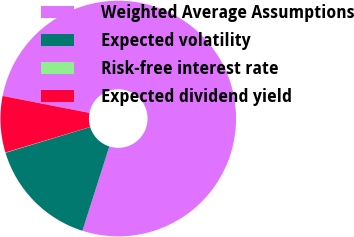Convert chart. <chart><loc_0><loc_0><loc_500><loc_500><pie_chart><fcel>Weighted Average Assumptions<fcel>Expected volatility<fcel>Risk-free interest rate<fcel>Expected dividend yield<nl><fcel>76.83%<fcel>15.4%<fcel>0.04%<fcel>7.72%<nl></chart> 